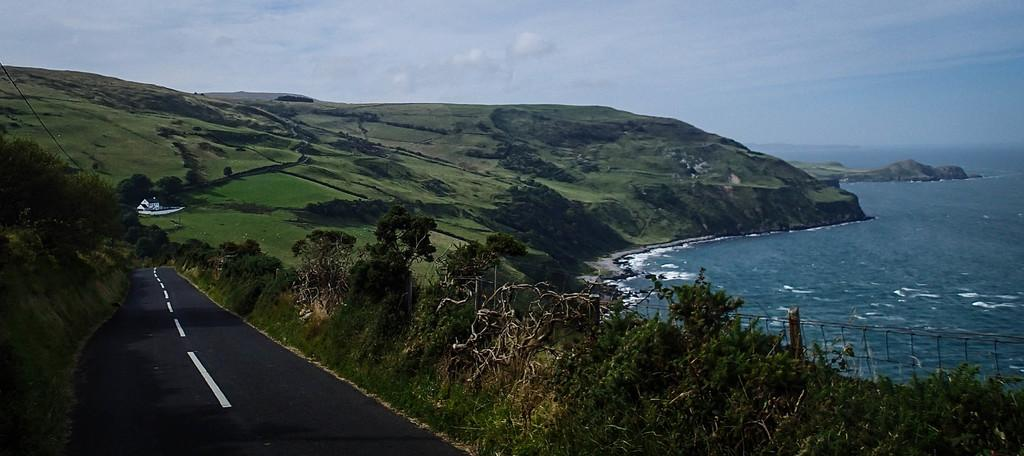What type of landscape can be seen in the image? There are hills in the image. What type of structure is present in the image? There is a building in the image. What type of pathway is visible in the image? There is a road in the image. What type of vegetation is present in the image? There are trees in the image. What type of water body is visible in the image? There is sea visible in the image. What part of the natural environment is visible in the image? The sky is visible in the image, and there are clouds in the sky. What type of riddle is being taught on the stage in the image? There is no stage or riddle present in the image. What type of teaching method is being used in the image? There is no teaching or method present in the image. 